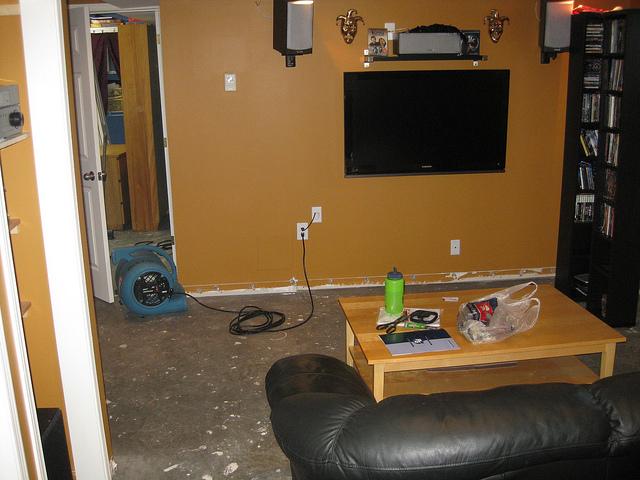Is the tv on?
Quick response, please. No. What color is the water bottle on the table?
Be succinct. Green. Which room is this?
Keep it brief. Living room. What is mounted on the wall?
Concise answer only. Tv. What type of door is in the room?
Give a very brief answer. Open. 